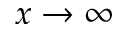Convert formula to latex. <formula><loc_0><loc_0><loc_500><loc_500>x \rightarrow \infty</formula> 